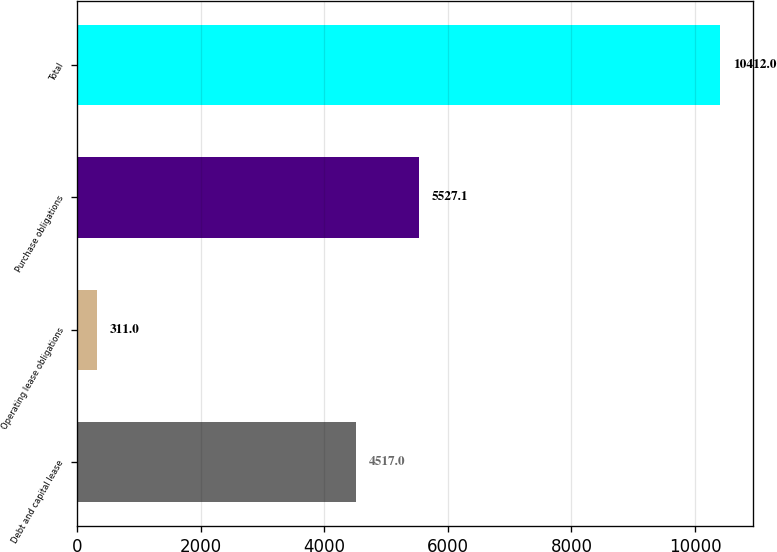<chart> <loc_0><loc_0><loc_500><loc_500><bar_chart><fcel>Debt and capital lease<fcel>Operating lease obligations<fcel>Purchase obligations<fcel>Total<nl><fcel>4517<fcel>311<fcel>5527.1<fcel>10412<nl></chart> 